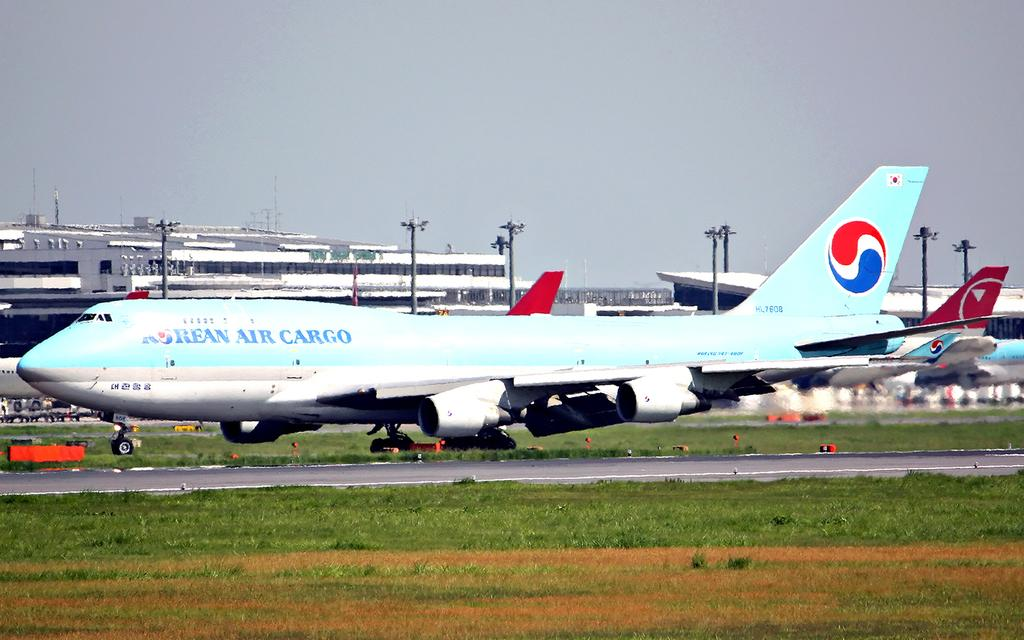Provide a one-sentence caption for the provided image. A blue and white Korean Air Cargo plane is parked on the grass. 